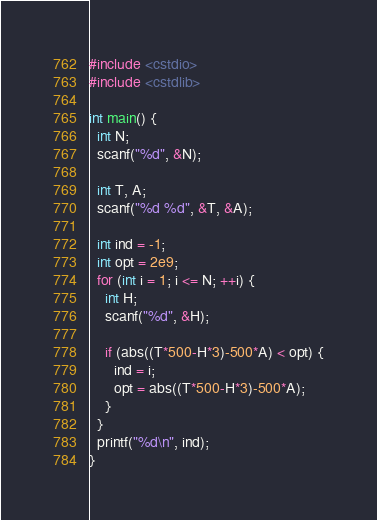<code> <loc_0><loc_0><loc_500><loc_500><_C++_>#include <cstdio>
#include <cstdlib>

int main() {
  int N;
  scanf("%d", &N);

  int T, A;
  scanf("%d %d", &T, &A);

  int ind = -1;
  int opt = 2e9;
  for (int i = 1; i <= N; ++i) {
    int H;
    scanf("%d", &H);

    if (abs((T*500-H*3)-500*A) < opt) {
      ind = i;
      opt = abs((T*500-H*3)-500*A);
    }
  }
  printf("%d\n", ind);
}</code> 